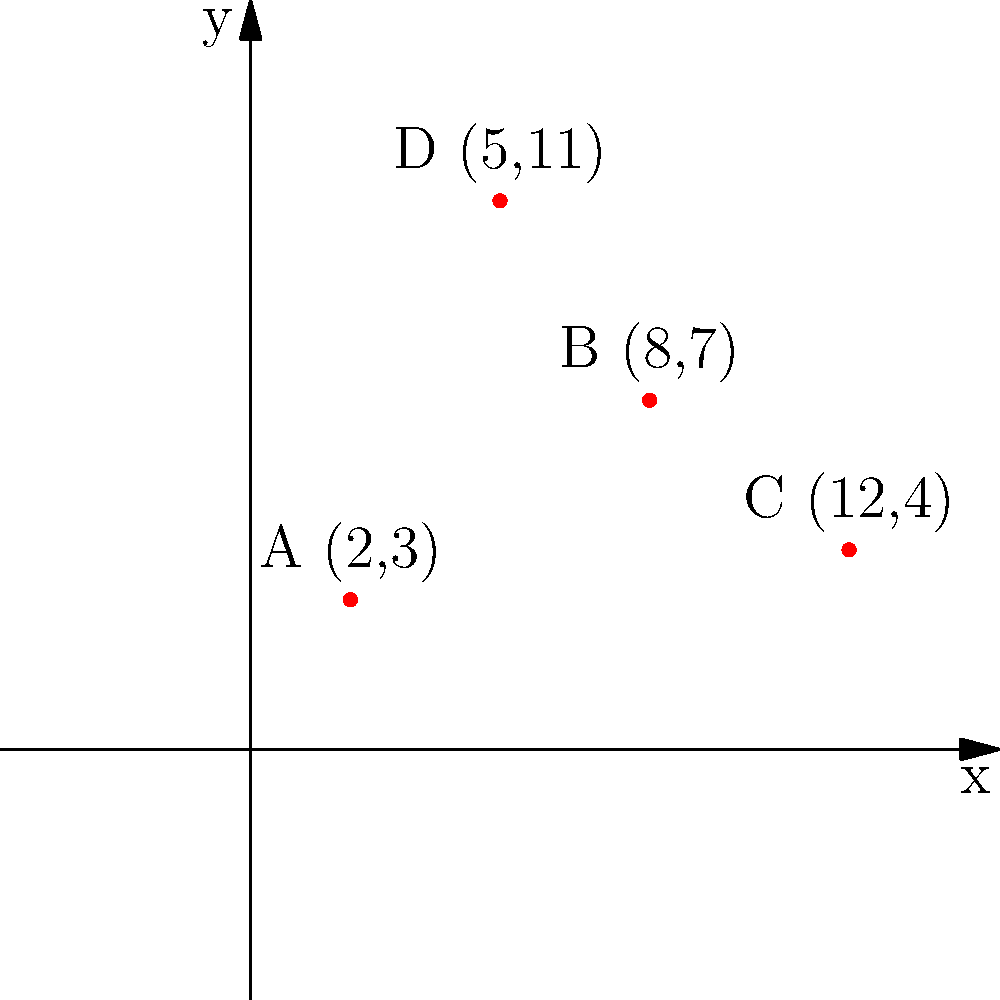As a food writer exploring Catalan cuisine, you've plotted the locations of four renowned restaurants in Barcelona on a coordinate plane. Restaurant A is at (2,3), B at (8,7), C at (12,4), and D at (5,11). If you're currently at restaurant A and want to visit the restaurant that's farthest away, which one should you choose? Calculate the distance between A and your chosen restaurant using the distance formula. To solve this problem, we need to follow these steps:

1. Recall the distance formula between two points (x₁, y₁) and (x₂, y₂):
   $$d = \sqrt{(x_2 - x_1)^2 + (y_2 - y_1)^2}$$

2. Calculate the distance between A and each of the other restaurants:

   For B (8,7):
   $$d_{AB} = \sqrt{(8 - 2)^2 + (7 - 3)^2} = \sqrt{6^2 + 4^2} = \sqrt{36 + 16} = \sqrt{52} \approx 7.21$$

   For C (12,4):
   $$d_{AC} = \sqrt{(12 - 2)^2 + (4 - 3)^2} = \sqrt{10^2 + 1^2} = \sqrt{100 + 1} = \sqrt{101} \approx 10.05$$

   For D (5,11):
   $$d_{AD} = \sqrt{(5 - 2)^2 + (11 - 3)^2} = \sqrt{3^2 + 8^2} = \sqrt{9 + 64} = \sqrt{73} \approx 8.54$$

3. Compare the distances:
   $d_{AC} > d_{AD} > d_{AB}$

4. The farthest restaurant from A is C, with a distance of $\sqrt{101}$.
Answer: Restaurant C, distance $\sqrt{101}$ 